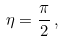Convert formula to latex. <formula><loc_0><loc_0><loc_500><loc_500>\eta = \frac { \pi } { 2 } \, ,</formula> 